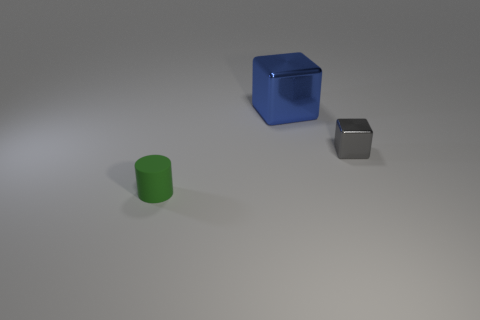Add 2 blue shiny blocks. How many objects exist? 5 Subtract all blocks. How many objects are left? 1 Add 3 large blocks. How many large blocks exist? 4 Subtract 0 yellow blocks. How many objects are left? 3 Subtract all big things. Subtract all gray blocks. How many objects are left? 1 Add 3 large blue metal objects. How many large blue metal objects are left? 4 